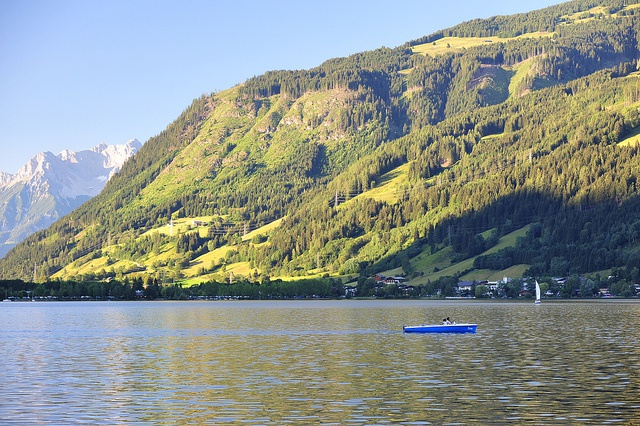Describe the objects in this image and their specific colors. I can see boat in lightblue, blue, darkblue, and white tones, boat in lightblue, lavender, and gray tones, people in lightblue, gray, lavender, and black tones, and people in lightblue, black, darkgray, gray, and lavender tones in this image. 